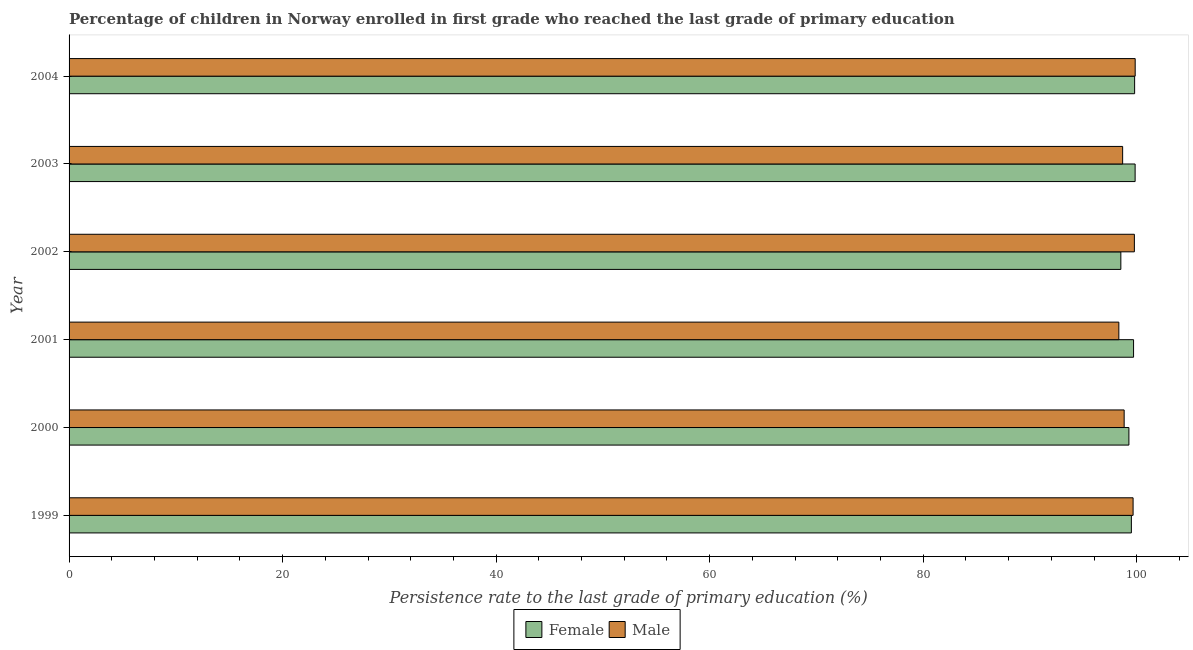How many different coloured bars are there?
Your answer should be compact. 2. How many groups of bars are there?
Your answer should be compact. 6. How many bars are there on the 2nd tick from the top?
Your answer should be compact. 2. How many bars are there on the 2nd tick from the bottom?
Offer a very short reply. 2. What is the persistence rate of female students in 2000?
Provide a short and direct response. 99.27. Across all years, what is the maximum persistence rate of female students?
Provide a succinct answer. 99.85. Across all years, what is the minimum persistence rate of female students?
Your response must be concise. 98.51. What is the total persistence rate of male students in the graph?
Ensure brevity in your answer.  595.13. What is the difference between the persistence rate of female students in 2000 and that in 2001?
Your answer should be compact. -0.44. What is the difference between the persistence rate of female students in 2000 and the persistence rate of male students in 1999?
Offer a very short reply. -0.39. What is the average persistence rate of male students per year?
Provide a succinct answer. 99.19. In the year 2000, what is the difference between the persistence rate of male students and persistence rate of female students?
Your answer should be compact. -0.45. What is the difference between the highest and the second highest persistence rate of female students?
Make the answer very short. 0.05. What is the difference between the highest and the lowest persistence rate of male students?
Provide a succinct answer. 1.53. In how many years, is the persistence rate of female students greater than the average persistence rate of female students taken over all years?
Make the answer very short. 4. What does the 2nd bar from the bottom in 2001 represents?
Ensure brevity in your answer.  Male. Are all the bars in the graph horizontal?
Keep it short and to the point. Yes. Are the values on the major ticks of X-axis written in scientific E-notation?
Your answer should be very brief. No. Does the graph contain any zero values?
Give a very brief answer. No. Does the graph contain grids?
Your response must be concise. No. What is the title of the graph?
Offer a terse response. Percentage of children in Norway enrolled in first grade who reached the last grade of primary education. Does "Number of departures" appear as one of the legend labels in the graph?
Offer a very short reply. No. What is the label or title of the X-axis?
Your answer should be compact. Persistence rate to the last grade of primary education (%). What is the label or title of the Y-axis?
Ensure brevity in your answer.  Year. What is the Persistence rate to the last grade of primary education (%) in Female in 1999?
Keep it short and to the point. 99.5. What is the Persistence rate to the last grade of primary education (%) in Male in 1999?
Your response must be concise. 99.66. What is the Persistence rate to the last grade of primary education (%) of Female in 2000?
Provide a succinct answer. 99.27. What is the Persistence rate to the last grade of primary education (%) in Male in 2000?
Make the answer very short. 98.82. What is the Persistence rate to the last grade of primary education (%) in Female in 2001?
Make the answer very short. 99.7. What is the Persistence rate to the last grade of primary education (%) in Male in 2001?
Make the answer very short. 98.33. What is the Persistence rate to the last grade of primary education (%) in Female in 2002?
Provide a short and direct response. 98.51. What is the Persistence rate to the last grade of primary education (%) of Male in 2002?
Offer a very short reply. 99.78. What is the Persistence rate to the last grade of primary education (%) of Female in 2003?
Your response must be concise. 99.85. What is the Persistence rate to the last grade of primary education (%) in Male in 2003?
Your answer should be very brief. 98.68. What is the Persistence rate to the last grade of primary education (%) of Female in 2004?
Keep it short and to the point. 99.8. What is the Persistence rate to the last grade of primary education (%) of Male in 2004?
Keep it short and to the point. 99.86. Across all years, what is the maximum Persistence rate to the last grade of primary education (%) in Female?
Make the answer very short. 99.85. Across all years, what is the maximum Persistence rate to the last grade of primary education (%) of Male?
Your answer should be very brief. 99.86. Across all years, what is the minimum Persistence rate to the last grade of primary education (%) in Female?
Your answer should be very brief. 98.51. Across all years, what is the minimum Persistence rate to the last grade of primary education (%) in Male?
Offer a very short reply. 98.33. What is the total Persistence rate to the last grade of primary education (%) of Female in the graph?
Your answer should be compact. 596.64. What is the total Persistence rate to the last grade of primary education (%) of Male in the graph?
Keep it short and to the point. 595.13. What is the difference between the Persistence rate to the last grade of primary education (%) in Female in 1999 and that in 2000?
Keep it short and to the point. 0.23. What is the difference between the Persistence rate to the last grade of primary education (%) in Male in 1999 and that in 2000?
Ensure brevity in your answer.  0.84. What is the difference between the Persistence rate to the last grade of primary education (%) of Female in 1999 and that in 2001?
Provide a succinct answer. -0.21. What is the difference between the Persistence rate to the last grade of primary education (%) in Male in 1999 and that in 2001?
Your response must be concise. 1.33. What is the difference between the Persistence rate to the last grade of primary education (%) in Female in 1999 and that in 2002?
Your answer should be very brief. 0.99. What is the difference between the Persistence rate to the last grade of primary education (%) in Male in 1999 and that in 2002?
Provide a short and direct response. -0.12. What is the difference between the Persistence rate to the last grade of primary education (%) in Female in 1999 and that in 2003?
Ensure brevity in your answer.  -0.35. What is the difference between the Persistence rate to the last grade of primary education (%) in Male in 1999 and that in 2003?
Ensure brevity in your answer.  0.98. What is the difference between the Persistence rate to the last grade of primary education (%) of Female in 1999 and that in 2004?
Offer a terse response. -0.3. What is the difference between the Persistence rate to the last grade of primary education (%) of Male in 1999 and that in 2004?
Provide a succinct answer. -0.2. What is the difference between the Persistence rate to the last grade of primary education (%) in Female in 2000 and that in 2001?
Provide a short and direct response. -0.44. What is the difference between the Persistence rate to the last grade of primary education (%) in Male in 2000 and that in 2001?
Offer a very short reply. 0.5. What is the difference between the Persistence rate to the last grade of primary education (%) of Female in 2000 and that in 2002?
Your response must be concise. 0.76. What is the difference between the Persistence rate to the last grade of primary education (%) in Male in 2000 and that in 2002?
Make the answer very short. -0.96. What is the difference between the Persistence rate to the last grade of primary education (%) of Female in 2000 and that in 2003?
Your response must be concise. -0.58. What is the difference between the Persistence rate to the last grade of primary education (%) of Male in 2000 and that in 2003?
Your response must be concise. 0.14. What is the difference between the Persistence rate to the last grade of primary education (%) in Female in 2000 and that in 2004?
Your answer should be very brief. -0.53. What is the difference between the Persistence rate to the last grade of primary education (%) in Male in 2000 and that in 2004?
Provide a succinct answer. -1.03. What is the difference between the Persistence rate to the last grade of primary education (%) in Female in 2001 and that in 2002?
Your answer should be compact. 1.19. What is the difference between the Persistence rate to the last grade of primary education (%) of Male in 2001 and that in 2002?
Ensure brevity in your answer.  -1.45. What is the difference between the Persistence rate to the last grade of primary education (%) of Female in 2001 and that in 2003?
Make the answer very short. -0.15. What is the difference between the Persistence rate to the last grade of primary education (%) of Male in 2001 and that in 2003?
Keep it short and to the point. -0.36. What is the difference between the Persistence rate to the last grade of primary education (%) in Female in 2001 and that in 2004?
Offer a terse response. -0.1. What is the difference between the Persistence rate to the last grade of primary education (%) of Male in 2001 and that in 2004?
Offer a terse response. -1.53. What is the difference between the Persistence rate to the last grade of primary education (%) of Female in 2002 and that in 2003?
Keep it short and to the point. -1.34. What is the difference between the Persistence rate to the last grade of primary education (%) of Male in 2002 and that in 2003?
Make the answer very short. 1.1. What is the difference between the Persistence rate to the last grade of primary education (%) in Female in 2002 and that in 2004?
Your answer should be compact. -1.29. What is the difference between the Persistence rate to the last grade of primary education (%) of Male in 2002 and that in 2004?
Your response must be concise. -0.08. What is the difference between the Persistence rate to the last grade of primary education (%) in Female in 2003 and that in 2004?
Your response must be concise. 0.05. What is the difference between the Persistence rate to the last grade of primary education (%) in Male in 2003 and that in 2004?
Give a very brief answer. -1.18. What is the difference between the Persistence rate to the last grade of primary education (%) in Female in 1999 and the Persistence rate to the last grade of primary education (%) in Male in 2000?
Your answer should be very brief. 0.68. What is the difference between the Persistence rate to the last grade of primary education (%) of Female in 1999 and the Persistence rate to the last grade of primary education (%) of Male in 2001?
Give a very brief answer. 1.17. What is the difference between the Persistence rate to the last grade of primary education (%) of Female in 1999 and the Persistence rate to the last grade of primary education (%) of Male in 2002?
Offer a terse response. -0.28. What is the difference between the Persistence rate to the last grade of primary education (%) of Female in 1999 and the Persistence rate to the last grade of primary education (%) of Male in 2003?
Your answer should be very brief. 0.82. What is the difference between the Persistence rate to the last grade of primary education (%) in Female in 1999 and the Persistence rate to the last grade of primary education (%) in Male in 2004?
Offer a very short reply. -0.36. What is the difference between the Persistence rate to the last grade of primary education (%) of Female in 2000 and the Persistence rate to the last grade of primary education (%) of Male in 2001?
Offer a very short reply. 0.94. What is the difference between the Persistence rate to the last grade of primary education (%) of Female in 2000 and the Persistence rate to the last grade of primary education (%) of Male in 2002?
Your response must be concise. -0.51. What is the difference between the Persistence rate to the last grade of primary education (%) in Female in 2000 and the Persistence rate to the last grade of primary education (%) in Male in 2003?
Ensure brevity in your answer.  0.59. What is the difference between the Persistence rate to the last grade of primary education (%) of Female in 2000 and the Persistence rate to the last grade of primary education (%) of Male in 2004?
Provide a short and direct response. -0.59. What is the difference between the Persistence rate to the last grade of primary education (%) in Female in 2001 and the Persistence rate to the last grade of primary education (%) in Male in 2002?
Give a very brief answer. -0.08. What is the difference between the Persistence rate to the last grade of primary education (%) in Female in 2001 and the Persistence rate to the last grade of primary education (%) in Male in 2003?
Your answer should be compact. 1.02. What is the difference between the Persistence rate to the last grade of primary education (%) of Female in 2001 and the Persistence rate to the last grade of primary education (%) of Male in 2004?
Make the answer very short. -0.15. What is the difference between the Persistence rate to the last grade of primary education (%) of Female in 2002 and the Persistence rate to the last grade of primary education (%) of Male in 2003?
Your response must be concise. -0.17. What is the difference between the Persistence rate to the last grade of primary education (%) in Female in 2002 and the Persistence rate to the last grade of primary education (%) in Male in 2004?
Make the answer very short. -1.34. What is the difference between the Persistence rate to the last grade of primary education (%) in Female in 2003 and the Persistence rate to the last grade of primary education (%) in Male in 2004?
Provide a succinct answer. -0.01. What is the average Persistence rate to the last grade of primary education (%) in Female per year?
Give a very brief answer. 99.44. What is the average Persistence rate to the last grade of primary education (%) in Male per year?
Your response must be concise. 99.19. In the year 1999, what is the difference between the Persistence rate to the last grade of primary education (%) of Female and Persistence rate to the last grade of primary education (%) of Male?
Keep it short and to the point. -0.16. In the year 2000, what is the difference between the Persistence rate to the last grade of primary education (%) in Female and Persistence rate to the last grade of primary education (%) in Male?
Make the answer very short. 0.45. In the year 2001, what is the difference between the Persistence rate to the last grade of primary education (%) of Female and Persistence rate to the last grade of primary education (%) of Male?
Provide a short and direct response. 1.38. In the year 2002, what is the difference between the Persistence rate to the last grade of primary education (%) of Female and Persistence rate to the last grade of primary education (%) of Male?
Ensure brevity in your answer.  -1.27. In the year 2003, what is the difference between the Persistence rate to the last grade of primary education (%) of Female and Persistence rate to the last grade of primary education (%) of Male?
Provide a short and direct response. 1.17. In the year 2004, what is the difference between the Persistence rate to the last grade of primary education (%) in Female and Persistence rate to the last grade of primary education (%) in Male?
Provide a succinct answer. -0.05. What is the ratio of the Persistence rate to the last grade of primary education (%) of Female in 1999 to that in 2000?
Your answer should be very brief. 1. What is the ratio of the Persistence rate to the last grade of primary education (%) of Male in 1999 to that in 2000?
Your response must be concise. 1.01. What is the ratio of the Persistence rate to the last grade of primary education (%) of Female in 1999 to that in 2001?
Your answer should be compact. 1. What is the ratio of the Persistence rate to the last grade of primary education (%) of Male in 1999 to that in 2001?
Provide a succinct answer. 1.01. What is the ratio of the Persistence rate to the last grade of primary education (%) in Female in 1999 to that in 2003?
Your response must be concise. 1. What is the ratio of the Persistence rate to the last grade of primary education (%) of Male in 1999 to that in 2003?
Give a very brief answer. 1.01. What is the ratio of the Persistence rate to the last grade of primary education (%) in Female in 2000 to that in 2001?
Your answer should be compact. 1. What is the ratio of the Persistence rate to the last grade of primary education (%) of Female in 2000 to that in 2002?
Provide a short and direct response. 1.01. What is the ratio of the Persistence rate to the last grade of primary education (%) in Male in 2000 to that in 2002?
Keep it short and to the point. 0.99. What is the ratio of the Persistence rate to the last grade of primary education (%) of Female in 2000 to that in 2003?
Keep it short and to the point. 0.99. What is the ratio of the Persistence rate to the last grade of primary education (%) in Female in 2000 to that in 2004?
Give a very brief answer. 0.99. What is the ratio of the Persistence rate to the last grade of primary education (%) of Male in 2000 to that in 2004?
Your answer should be very brief. 0.99. What is the ratio of the Persistence rate to the last grade of primary education (%) in Female in 2001 to that in 2002?
Provide a short and direct response. 1.01. What is the ratio of the Persistence rate to the last grade of primary education (%) in Male in 2001 to that in 2002?
Your response must be concise. 0.99. What is the ratio of the Persistence rate to the last grade of primary education (%) in Female in 2001 to that in 2003?
Your answer should be compact. 1. What is the ratio of the Persistence rate to the last grade of primary education (%) of Male in 2001 to that in 2003?
Your answer should be very brief. 1. What is the ratio of the Persistence rate to the last grade of primary education (%) in Female in 2001 to that in 2004?
Your answer should be compact. 1. What is the ratio of the Persistence rate to the last grade of primary education (%) in Male in 2001 to that in 2004?
Offer a terse response. 0.98. What is the ratio of the Persistence rate to the last grade of primary education (%) in Female in 2002 to that in 2003?
Keep it short and to the point. 0.99. What is the ratio of the Persistence rate to the last grade of primary education (%) in Male in 2002 to that in 2003?
Offer a very short reply. 1.01. What is the ratio of the Persistence rate to the last grade of primary education (%) in Female in 2002 to that in 2004?
Ensure brevity in your answer.  0.99. What is the ratio of the Persistence rate to the last grade of primary education (%) in Male in 2002 to that in 2004?
Make the answer very short. 1. What is the difference between the highest and the second highest Persistence rate to the last grade of primary education (%) of Female?
Offer a very short reply. 0.05. What is the difference between the highest and the second highest Persistence rate to the last grade of primary education (%) of Male?
Your answer should be compact. 0.08. What is the difference between the highest and the lowest Persistence rate to the last grade of primary education (%) in Female?
Make the answer very short. 1.34. What is the difference between the highest and the lowest Persistence rate to the last grade of primary education (%) in Male?
Make the answer very short. 1.53. 